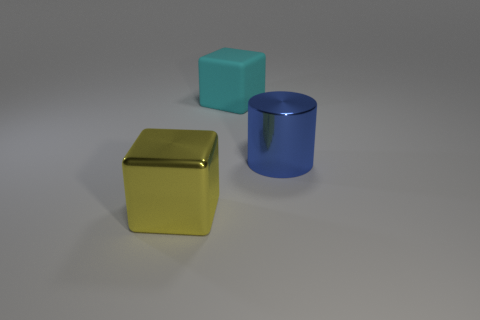Subtract all yellow cubes. Subtract all red spheres. How many cubes are left? 1 Add 2 gray metal blocks. How many objects exist? 5 Subtract all cubes. How many objects are left? 1 Add 3 large cyan matte things. How many large cyan matte things are left? 4 Add 2 large gray rubber balls. How many large gray rubber balls exist? 2 Subtract 0 purple balls. How many objects are left? 3 Subtract all big blue cylinders. Subtract all large yellow matte things. How many objects are left? 2 